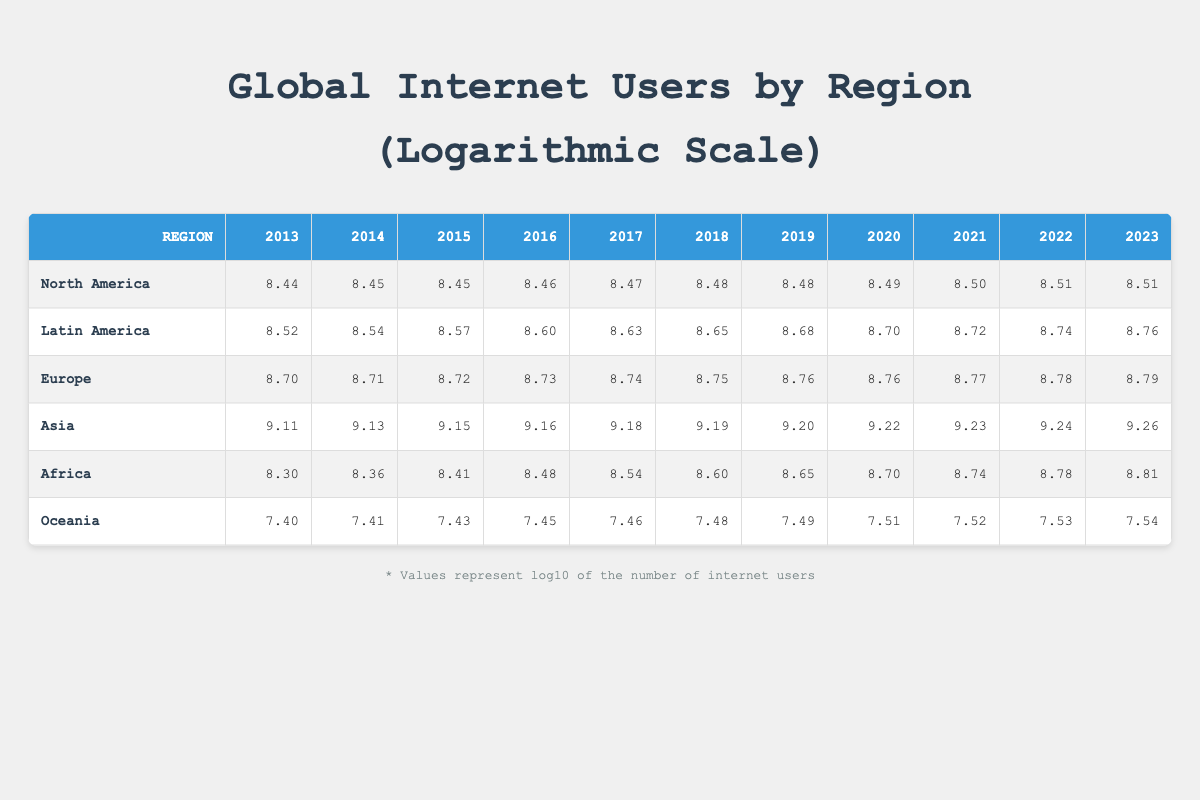What was the total number of internet users in Africa in 2020? According to the table, the number of internet users in Africa in 2020 is listed as 500000000. Therefore, the total number of internet users in Africa in that year is simply the value shown in the table.
Answer: 500000000 Which region saw the highest increase in internet users from 2013 to 2023? To find this, we look at the internet user values in 2013 and 2023 for each region. For Africa, the increase is from 200000000 to 650000000, which is a change of 450000000. For Asia, it goes from 1300000000 to 1800000000, a change of 500000000, the highest increase.
Answer: Asia What was the logarithmic value of internet users in Europe in 2015? The table shows that the logarithmic value for Europe in 2015 is 8.72. We can simply refer to that specific year and region in the table to get the answer directly.
Answer: 8.72 Is the number of internet users in Oceania increasing every year? By observing the values for Oceania from 2013 to 2023, we can see that it rises consistently each year: 25000000, 26000000, 27000000, 28000000, 29000000, 30000000, 31000000, 32000000, 33000000, and 34000000. Thus, the answer is yes, as it does not decline in any year.
Answer: Yes What is the average number of internet users in Latin America over the last decade? We take the values from each year in Latin America: 328000000, 350000000, 375000000, 400000000, 425000000, 450000000, 475000000, 500000000, 525000000, 550000000, and 575000000. The sum of these values is 5,637,500,000. Dividing by 11 (the number of years) gives an average of 512500000.
Answer: 512500000 Which region had the least number of internet users in 2014? The values for 2014 are as follows: North America 280000000, Latin America 350000000, Europe 517000000, Asia 1350000000, Africa 230000000, and Oceania 26000000. The lowest amount is found in Oceania with 26000000.
Answer: Oceania What is the difference in logarithmic values of internet users from Africa in 2013 and 2023? Looking at the logarithmic values, in 2013 Africa was at 8.30 and by 2023 it had risen to 8.81. To find the difference, we subtract: 8.81 - 8.30 = 0.51.
Answer: 0.51 In which year did Europe see an increase from 8.70 to at least 8.74? Reviewing the European data, it stays at 8.70 in 2013 and 8.71 in 2014. The value increases to 8.72 in 2015 and reaches at least 8.74 in 2016. Hence, the year where it first reaches at least 8.74 is 2016.
Answer: 2016 What percentage increase in internet users did Asia have from 2013 to 2023? The value for Asia in 2013 is 1300000000 and in 2023 it is 1800000000. The increase is calculated by (1800000000 - 1300000000) / 1300000000 * 100 = 38.46%. This percentage reflects the change in the number of internet users over this period.
Answer: 38.46% 